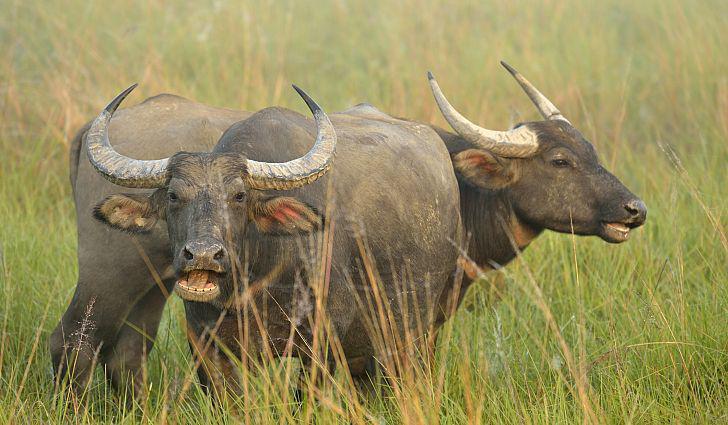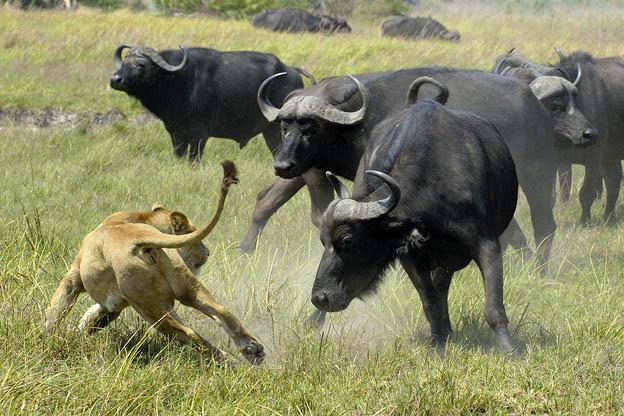The first image is the image on the left, the second image is the image on the right. For the images shown, is this caption "One of the images contains one baby water buffalo." true? Answer yes or no. No. 